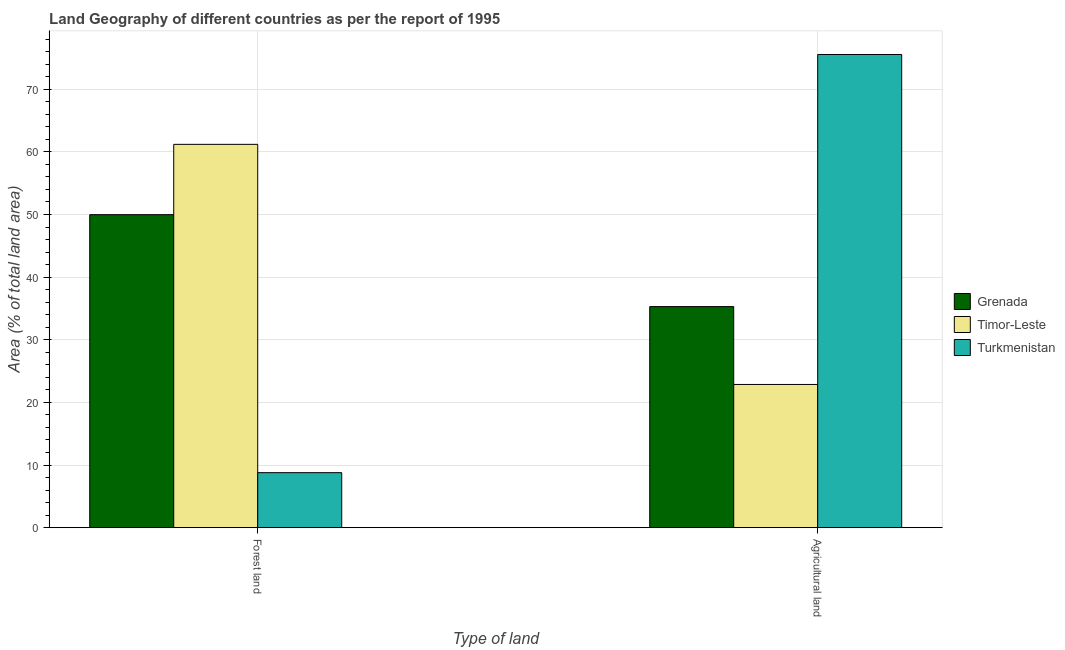How many groups of bars are there?
Offer a terse response. 2. Are the number of bars per tick equal to the number of legend labels?
Provide a short and direct response. Yes. Are the number of bars on each tick of the X-axis equal?
Your response must be concise. Yes. What is the label of the 1st group of bars from the left?
Give a very brief answer. Forest land. What is the percentage of land area under agriculture in Turkmenistan?
Your answer should be compact. 75.54. Across all countries, what is the maximum percentage of land area under agriculture?
Offer a terse response. 75.54. Across all countries, what is the minimum percentage of land area under agriculture?
Offer a terse response. 22.86. In which country was the percentage of land area under forests maximum?
Provide a succinct answer. Timor-Leste. In which country was the percentage of land area under forests minimum?
Offer a terse response. Turkmenistan. What is the total percentage of land area under agriculture in the graph?
Offer a terse response. 133.7. What is the difference between the percentage of land area under forests in Grenada and that in Timor-Leste?
Offer a terse response. -11.23. What is the difference between the percentage of land area under forests in Turkmenistan and the percentage of land area under agriculture in Timor-Leste?
Keep it short and to the point. -14.08. What is the average percentage of land area under agriculture per country?
Keep it short and to the point. 44.57. What is the difference between the percentage of land area under agriculture and percentage of land area under forests in Timor-Leste?
Provide a succinct answer. -38.33. In how many countries, is the percentage of land area under agriculture greater than 50 %?
Provide a succinct answer. 1. What is the ratio of the percentage of land area under forests in Grenada to that in Timor-Leste?
Provide a short and direct response. 0.82. What does the 3rd bar from the left in Forest land represents?
Provide a succinct answer. Turkmenistan. What does the 1st bar from the right in Agricultural land represents?
Offer a terse response. Turkmenistan. How many bars are there?
Offer a terse response. 6. Are all the bars in the graph horizontal?
Provide a succinct answer. No. Are the values on the major ticks of Y-axis written in scientific E-notation?
Keep it short and to the point. No. Where does the legend appear in the graph?
Give a very brief answer. Center right. What is the title of the graph?
Offer a very short reply. Land Geography of different countries as per the report of 1995. What is the label or title of the X-axis?
Offer a very short reply. Type of land. What is the label or title of the Y-axis?
Ensure brevity in your answer.  Area (% of total land area). What is the Area (% of total land area) in Grenada in Forest land?
Provide a short and direct response. 49.97. What is the Area (% of total land area) of Timor-Leste in Forest land?
Your response must be concise. 61.2. What is the Area (% of total land area) in Turkmenistan in Forest land?
Provide a short and direct response. 8.78. What is the Area (% of total land area) of Grenada in Agricultural land?
Provide a short and direct response. 35.29. What is the Area (% of total land area) in Timor-Leste in Agricultural land?
Provide a short and direct response. 22.86. What is the Area (% of total land area) in Turkmenistan in Agricultural land?
Offer a terse response. 75.54. Across all Type of land, what is the maximum Area (% of total land area) in Grenada?
Make the answer very short. 49.97. Across all Type of land, what is the maximum Area (% of total land area) of Timor-Leste?
Ensure brevity in your answer.  61.2. Across all Type of land, what is the maximum Area (% of total land area) in Turkmenistan?
Provide a succinct answer. 75.54. Across all Type of land, what is the minimum Area (% of total land area) of Grenada?
Your response must be concise. 35.29. Across all Type of land, what is the minimum Area (% of total land area) in Timor-Leste?
Your answer should be compact. 22.86. Across all Type of land, what is the minimum Area (% of total land area) of Turkmenistan?
Give a very brief answer. 8.78. What is the total Area (% of total land area) in Grenada in the graph?
Keep it short and to the point. 85.26. What is the total Area (% of total land area) of Timor-Leste in the graph?
Give a very brief answer. 84.06. What is the total Area (% of total land area) of Turkmenistan in the graph?
Your answer should be compact. 84.33. What is the difference between the Area (% of total land area) of Grenada in Forest land and that in Agricultural land?
Offer a terse response. 14.68. What is the difference between the Area (% of total land area) in Timor-Leste in Forest land and that in Agricultural land?
Your answer should be very brief. 38.33. What is the difference between the Area (% of total land area) of Turkmenistan in Forest land and that in Agricultural land?
Keep it short and to the point. -66.76. What is the difference between the Area (% of total land area) of Grenada in Forest land and the Area (% of total land area) of Timor-Leste in Agricultural land?
Ensure brevity in your answer.  27.11. What is the difference between the Area (% of total land area) of Grenada in Forest land and the Area (% of total land area) of Turkmenistan in Agricultural land?
Give a very brief answer. -25.57. What is the difference between the Area (% of total land area) in Timor-Leste in Forest land and the Area (% of total land area) in Turkmenistan in Agricultural land?
Provide a succinct answer. -14.35. What is the average Area (% of total land area) of Grenada per Type of land?
Ensure brevity in your answer.  42.63. What is the average Area (% of total land area) of Timor-Leste per Type of land?
Provide a succinct answer. 42.03. What is the average Area (% of total land area) of Turkmenistan per Type of land?
Keep it short and to the point. 42.16. What is the difference between the Area (% of total land area) in Grenada and Area (% of total land area) in Timor-Leste in Forest land?
Give a very brief answer. -11.23. What is the difference between the Area (% of total land area) of Grenada and Area (% of total land area) of Turkmenistan in Forest land?
Provide a short and direct response. 41.19. What is the difference between the Area (% of total land area) of Timor-Leste and Area (% of total land area) of Turkmenistan in Forest land?
Provide a succinct answer. 52.41. What is the difference between the Area (% of total land area) of Grenada and Area (% of total land area) of Timor-Leste in Agricultural land?
Your answer should be compact. 12.43. What is the difference between the Area (% of total land area) of Grenada and Area (% of total land area) of Turkmenistan in Agricultural land?
Keep it short and to the point. -40.25. What is the difference between the Area (% of total land area) of Timor-Leste and Area (% of total land area) of Turkmenistan in Agricultural land?
Give a very brief answer. -52.68. What is the ratio of the Area (% of total land area) of Grenada in Forest land to that in Agricultural land?
Your answer should be compact. 1.42. What is the ratio of the Area (% of total land area) in Timor-Leste in Forest land to that in Agricultural land?
Your answer should be very brief. 2.68. What is the ratio of the Area (% of total land area) of Turkmenistan in Forest land to that in Agricultural land?
Ensure brevity in your answer.  0.12. What is the difference between the highest and the second highest Area (% of total land area) in Grenada?
Provide a short and direct response. 14.68. What is the difference between the highest and the second highest Area (% of total land area) of Timor-Leste?
Ensure brevity in your answer.  38.33. What is the difference between the highest and the second highest Area (% of total land area) of Turkmenistan?
Offer a very short reply. 66.76. What is the difference between the highest and the lowest Area (% of total land area) of Grenada?
Your answer should be compact. 14.68. What is the difference between the highest and the lowest Area (% of total land area) of Timor-Leste?
Provide a short and direct response. 38.33. What is the difference between the highest and the lowest Area (% of total land area) of Turkmenistan?
Your response must be concise. 66.76. 